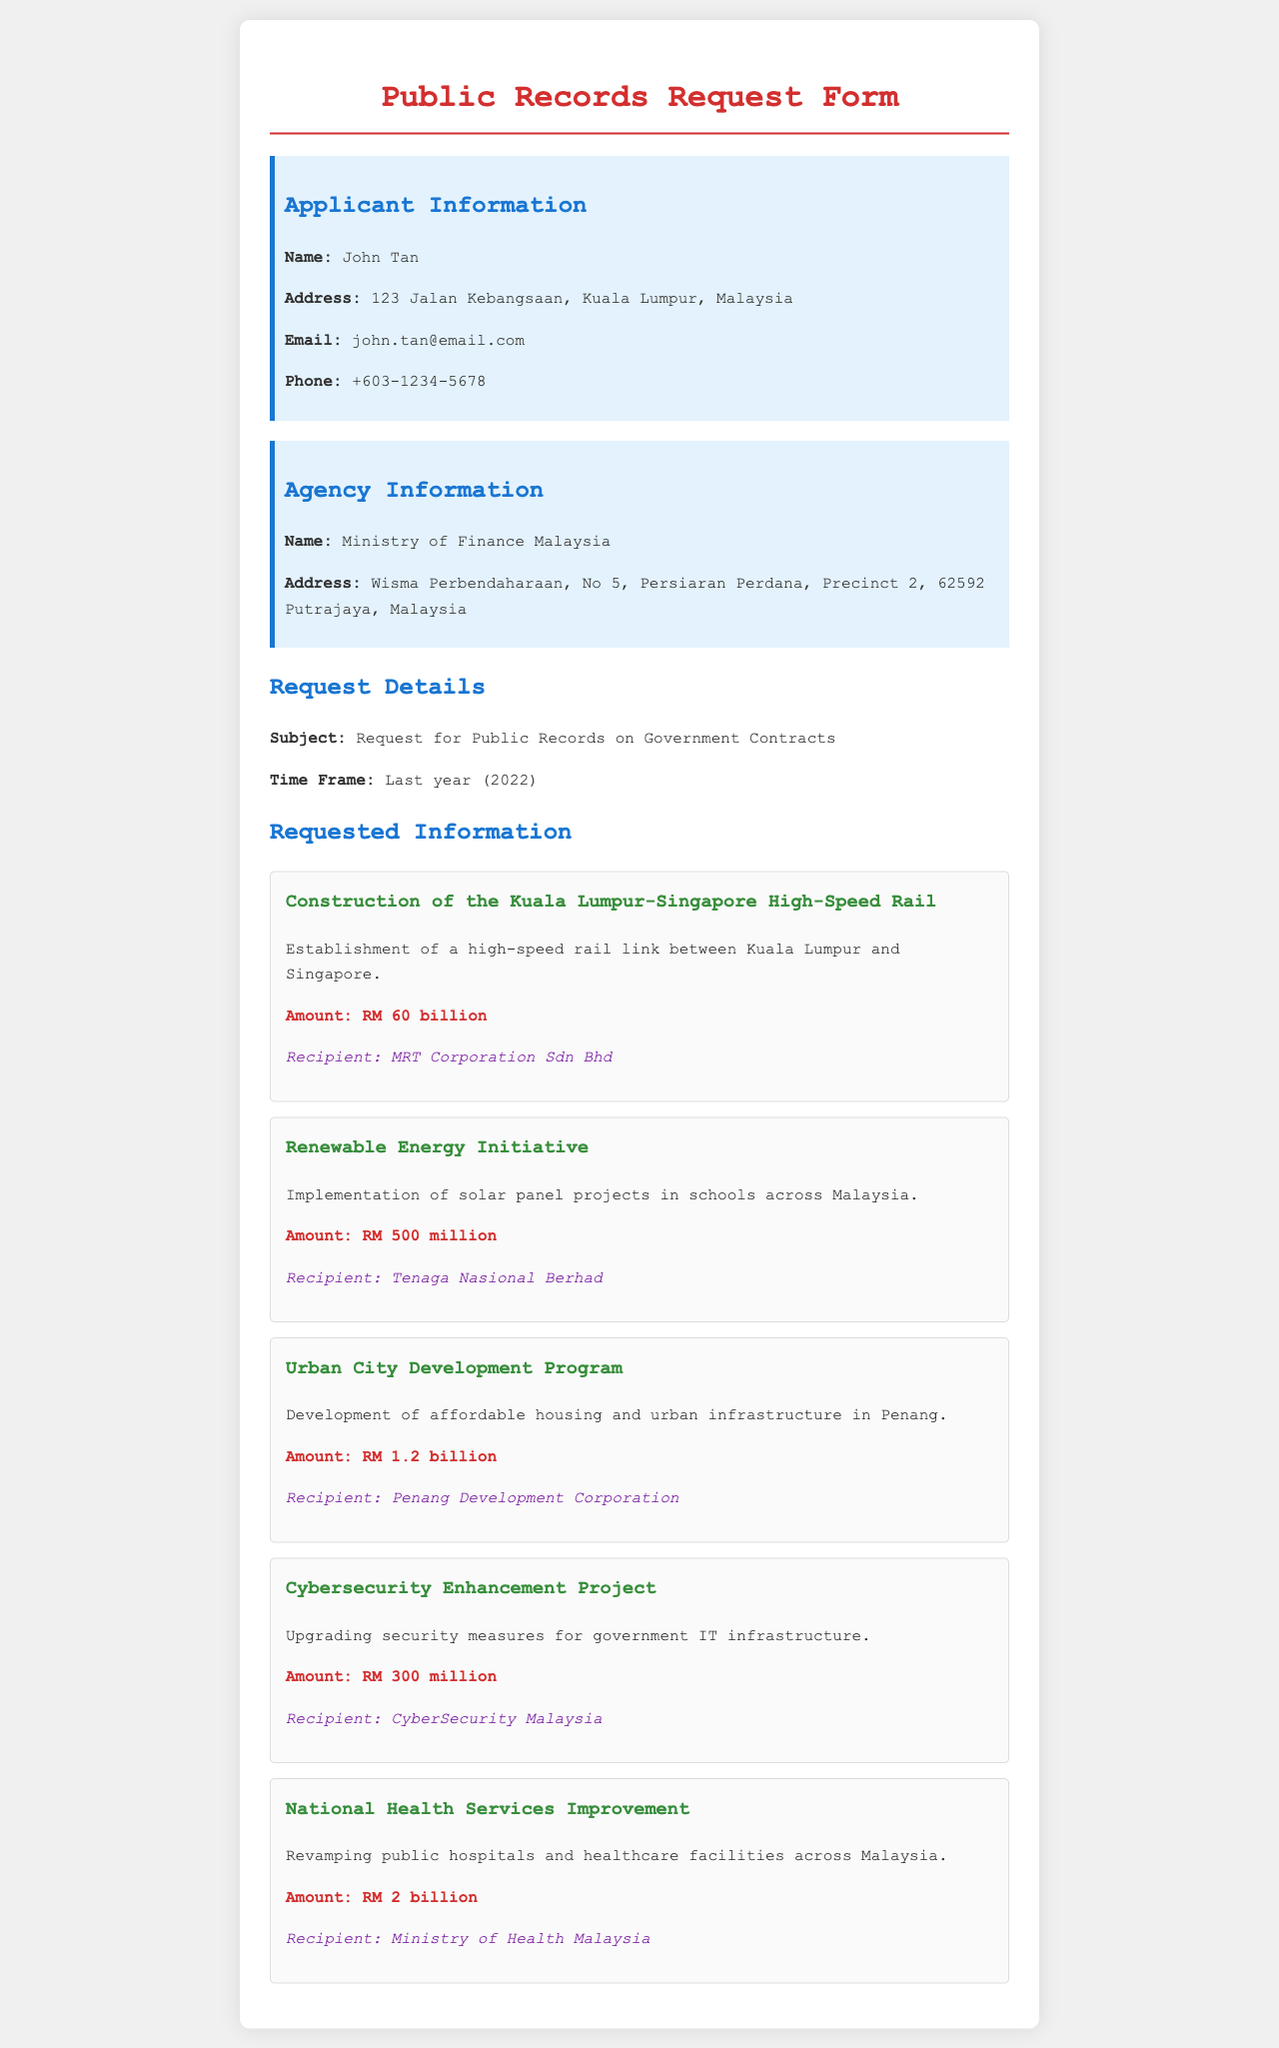What is the applicant's name? The applicant's name is clearly stated in the document.
Answer: John Tan Which agency is the request directed to? The document specifies the agency to which the request is made.
Answer: Ministry of Finance Malaysia How much was allocated for the construction of the Kuala Lumpur-Singapore High-Speed Rail? The amount is directly mentioned in the project section for this specific initiative.
Answer: RM 60 billion What is the focus of the Renewable Energy Initiative? The document provides a brief project summary related to the Renewable Energy Initiative.
Answer: Solar panel projects in schools Who is the recipient of the Urban City Development Program? The recipient is identified in the project details for this specific program.
Answer: Penang Development Corporation What was the total amount requested for the Cybersecurity Enhancement Project? The document specifies the amount allocated for this particular project.
Answer: RM 300 million What type of information is being requested in this document? The subject line of the request provides insight into the type of information sought.
Answer: Public Records on Government Contracts Who is responsible for the National Health Services Improvement project? The recipient is explicitly mentioned in the project details for this initiative.
Answer: Ministry of Health Malaysia How many projects are listed in the request? The total number of project sections can be easily counted in the document.
Answer: Five 